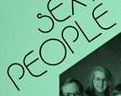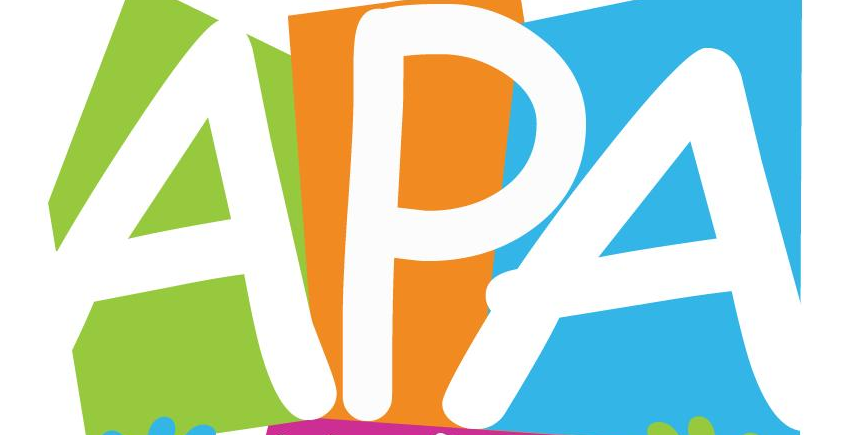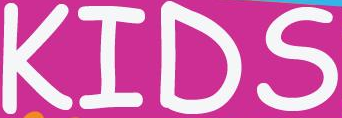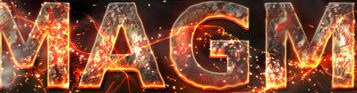What words are shown in these images in order, separated by a semicolon? PEOPLE; APA; KIDS; MAGM 